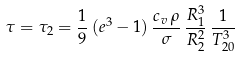<formula> <loc_0><loc_0><loc_500><loc_500>\tau = \tau _ { 2 } = \frac { 1 } { 9 } \, ( e ^ { 3 } - 1 ) \, \frac { c _ { v } \, \rho } { \sigma } \, \frac { R _ { 1 } ^ { 3 } } { R _ { 2 } ^ { 2 } } \, \frac { 1 } { T _ { 2 0 } ^ { 3 } }</formula> 